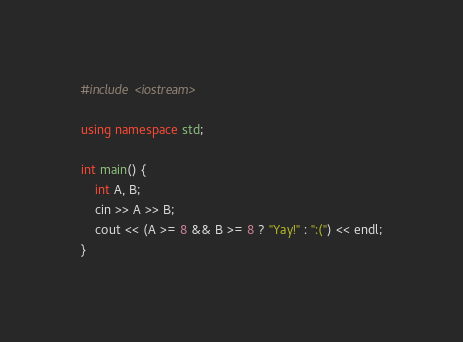Convert code to text. <code><loc_0><loc_0><loc_500><loc_500><_C++_>#include <iostream>

using namespace std;

int main() {
    int A, B;
    cin >> A >> B;
    cout << (A >= 8 && B >= 8 ? "Yay!" : ":(") << endl;
}</code> 